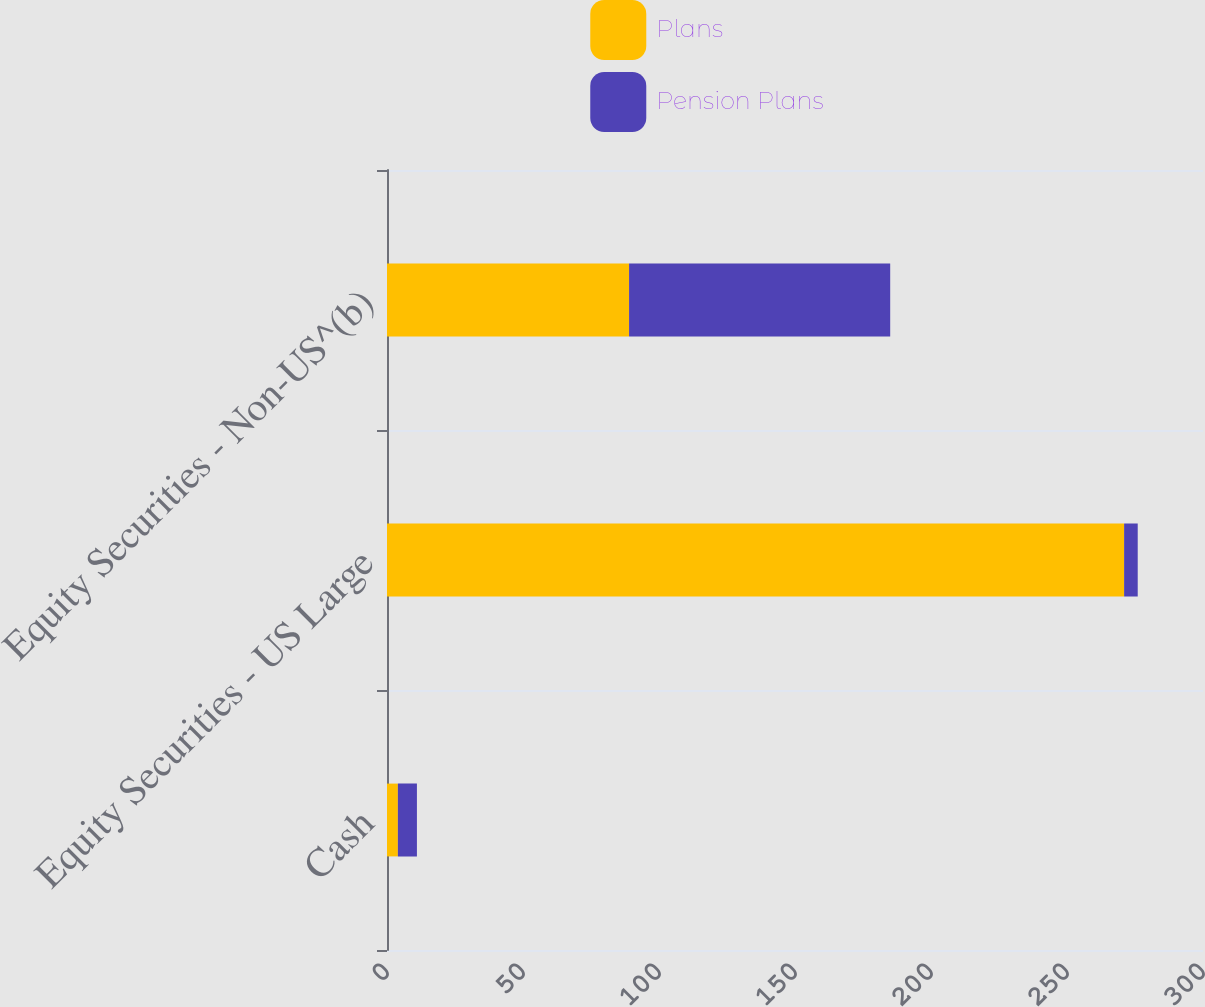Convert chart. <chart><loc_0><loc_0><loc_500><loc_500><stacked_bar_chart><ecel><fcel>Cash<fcel>Equity Securities - US Large<fcel>Equity Securities - Non-US^(b)<nl><fcel>Plans<fcel>4<fcel>271<fcel>89<nl><fcel>Pension Plans<fcel>7<fcel>5<fcel>96<nl></chart> 